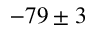<formula> <loc_0><loc_0><loc_500><loc_500>- 7 9 \pm 3</formula> 